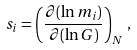Convert formula to latex. <formula><loc_0><loc_0><loc_500><loc_500>s _ { i } = \left ( \frac { \partial ( \ln m _ { i } ) } { \partial ( \ln G ) } \right ) _ { N } \, ,</formula> 